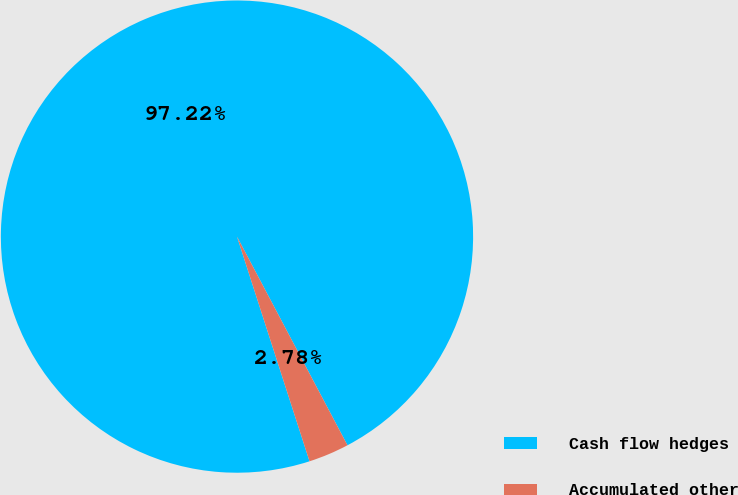Convert chart. <chart><loc_0><loc_0><loc_500><loc_500><pie_chart><fcel>Cash flow hedges<fcel>Accumulated other<nl><fcel>97.22%<fcel>2.78%<nl></chart> 